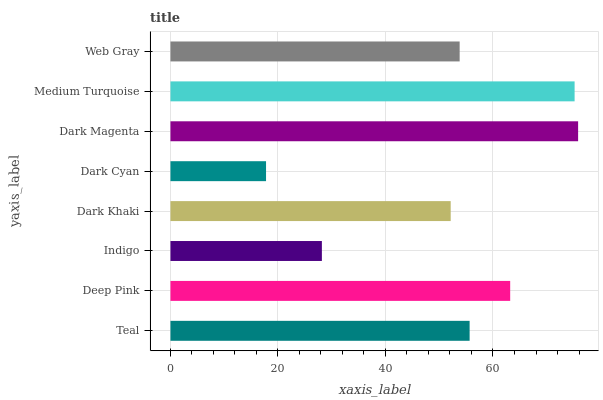Is Dark Cyan the minimum?
Answer yes or no. Yes. Is Dark Magenta the maximum?
Answer yes or no. Yes. Is Deep Pink the minimum?
Answer yes or no. No. Is Deep Pink the maximum?
Answer yes or no. No. Is Deep Pink greater than Teal?
Answer yes or no. Yes. Is Teal less than Deep Pink?
Answer yes or no. Yes. Is Teal greater than Deep Pink?
Answer yes or no. No. Is Deep Pink less than Teal?
Answer yes or no. No. Is Teal the high median?
Answer yes or no. Yes. Is Web Gray the low median?
Answer yes or no. Yes. Is Web Gray the high median?
Answer yes or no. No. Is Dark Khaki the low median?
Answer yes or no. No. 